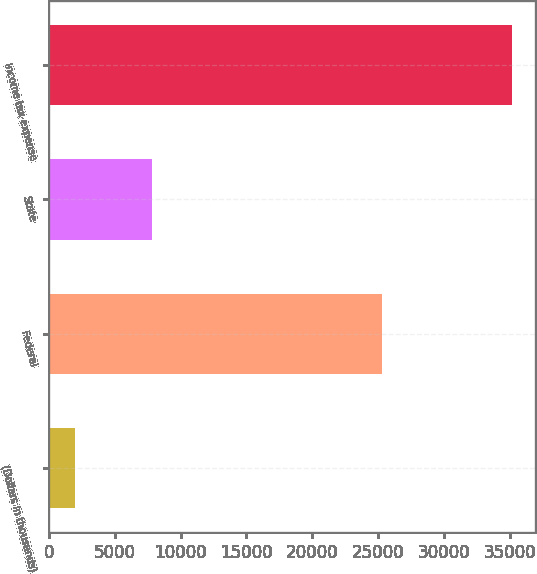Convert chart. <chart><loc_0><loc_0><loc_500><loc_500><bar_chart><fcel>(Dollars in thousands)<fcel>Federal<fcel>State<fcel>Income tax expense<nl><fcel>2009<fcel>25300<fcel>7813<fcel>35207<nl></chart> 